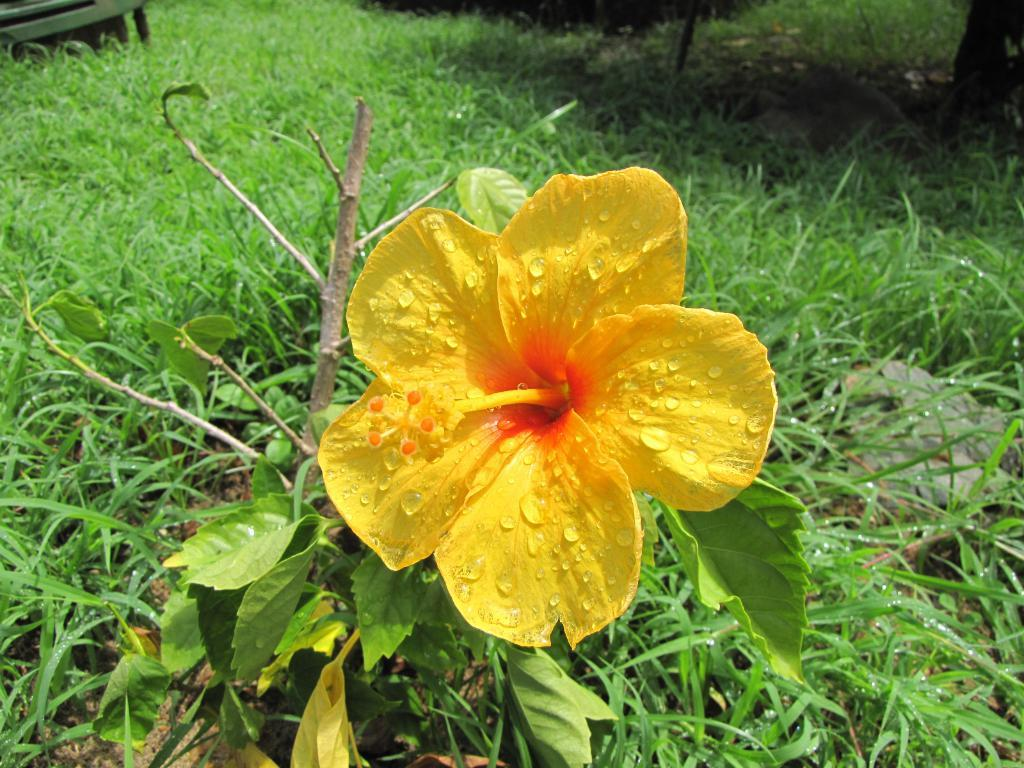What is the main subject of the image? There is a flower in the image. What type of vegetation can be seen in the background of the image? There is grass visible in the background of the image. What type of oil can be seen dripping from the flower in the image? There is no oil present in the image; it features a flower and grass. How many nuts are visible on the flower in the image? There are no nuts present in the image; it features a flower and grass. 